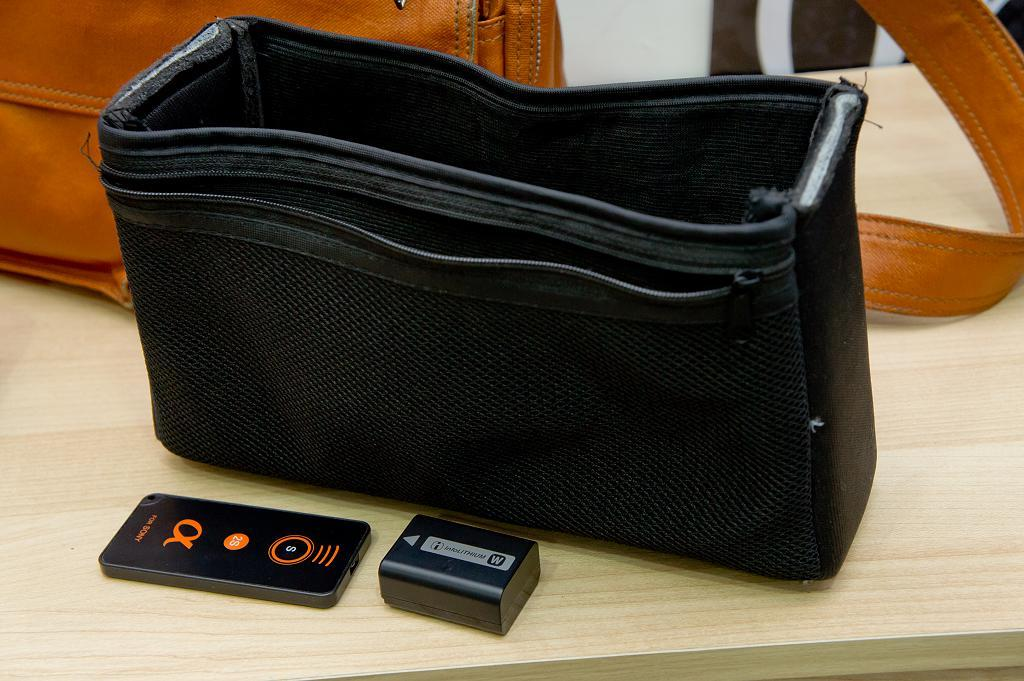What is the main object in the center of the image? There is a table in the center of the image. What items can be seen on the table? There is a bag, an iPod, a connector, and an orange-colored handbag on the table. How many zebras are visible in the image? There are no zebras present in the image. What type of planes can be seen flying in the background of the image? There is no background or planes visible in the image; it only shows a table with items on it. 